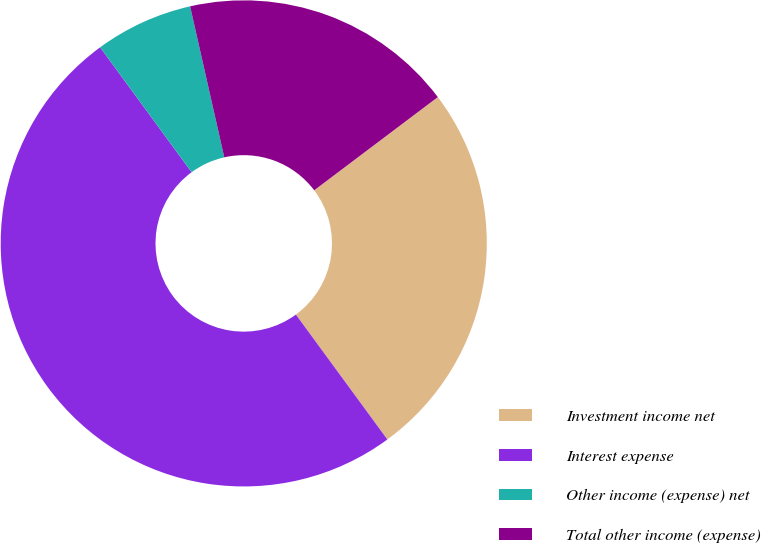Convert chart. <chart><loc_0><loc_0><loc_500><loc_500><pie_chart><fcel>Investment income net<fcel>Interest expense<fcel>Other income (expense) net<fcel>Total other income (expense)<nl><fcel>25.22%<fcel>50.0%<fcel>6.52%<fcel>18.26%<nl></chart> 